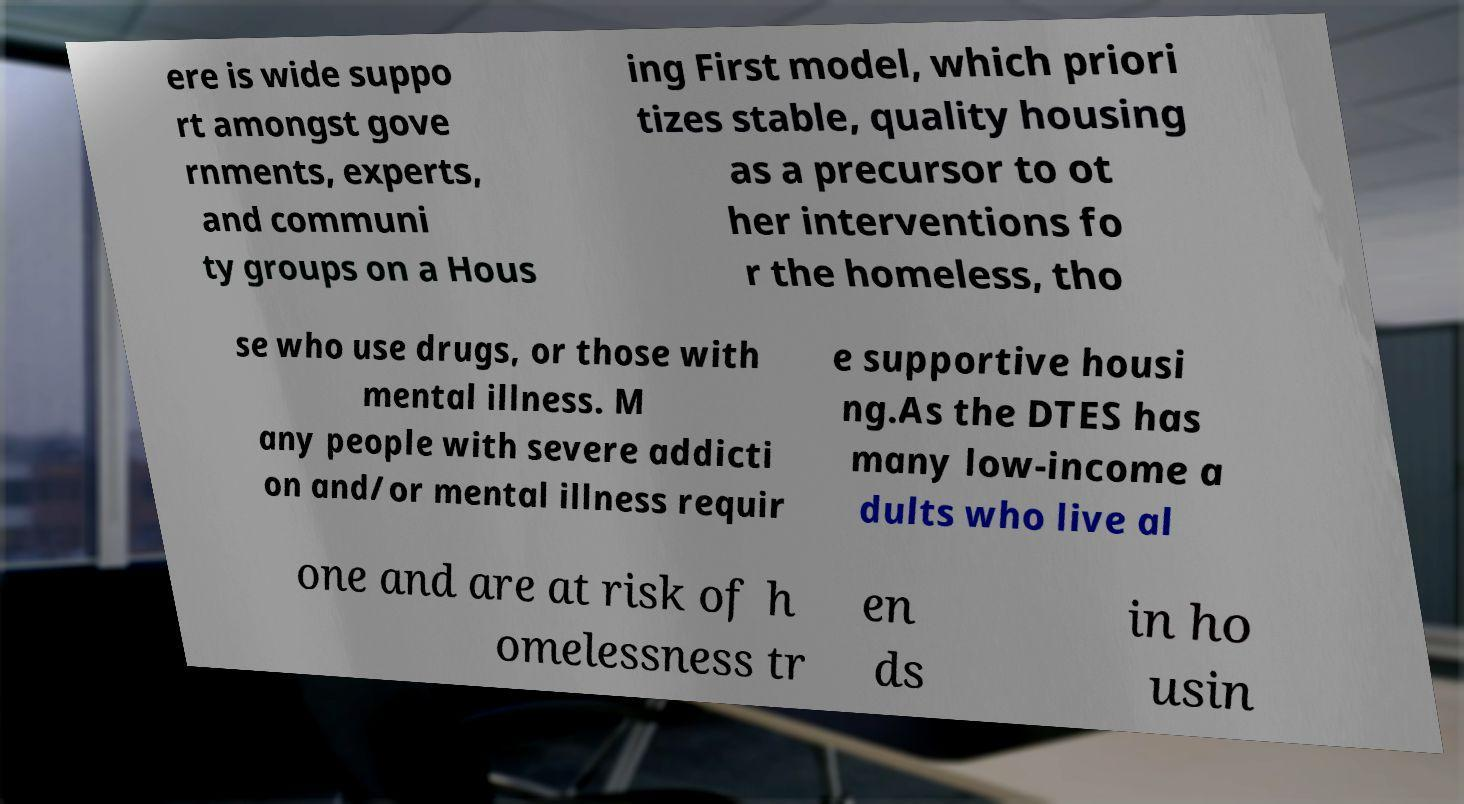Could you extract and type out the text from this image? ere is wide suppo rt amongst gove rnments, experts, and communi ty groups on a Hous ing First model, which priori tizes stable, quality housing as a precursor to ot her interventions fo r the homeless, tho se who use drugs, or those with mental illness. M any people with severe addicti on and/or mental illness requir e supportive housi ng.As the DTES has many low-income a dults who live al one and are at risk of h omelessness tr en ds in ho usin 